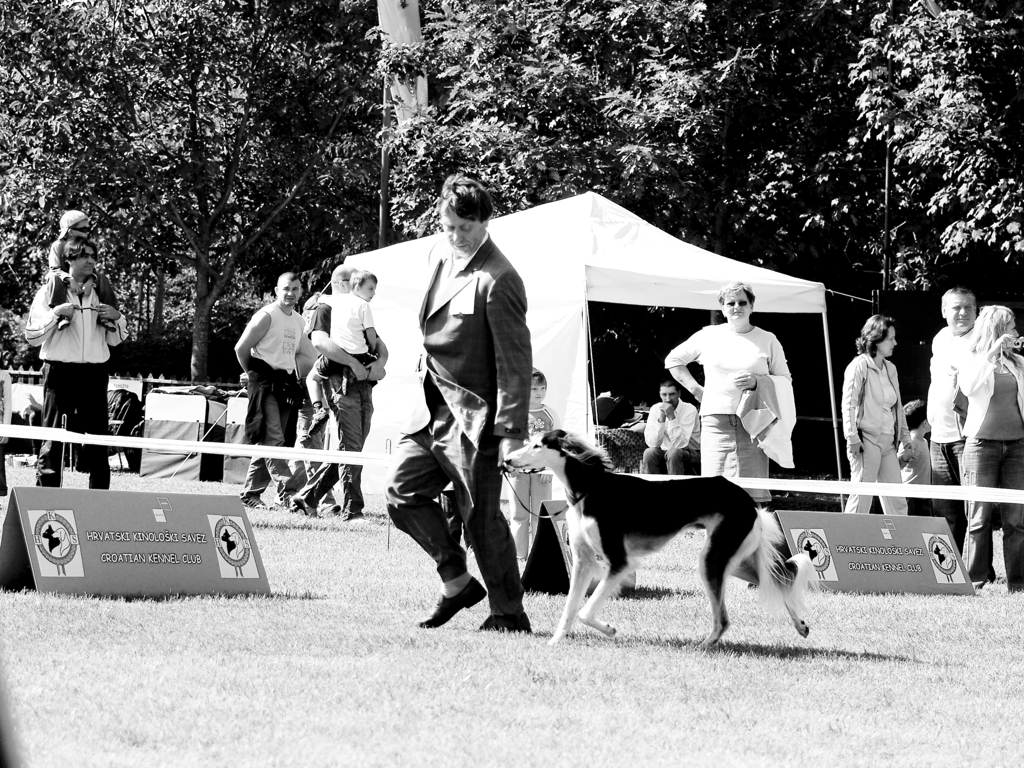Can you tell me what kind of event is being depicted in this photograph? Certainly! This image captures a moment from an outdoor event that resembles a dog show. We can see various people gathered around, and there are banners with the logos of the Croatian Kennel Club, which suggests that this is a formal event focused on dogs, possibly involving competition or exhibition of canine breeds. 